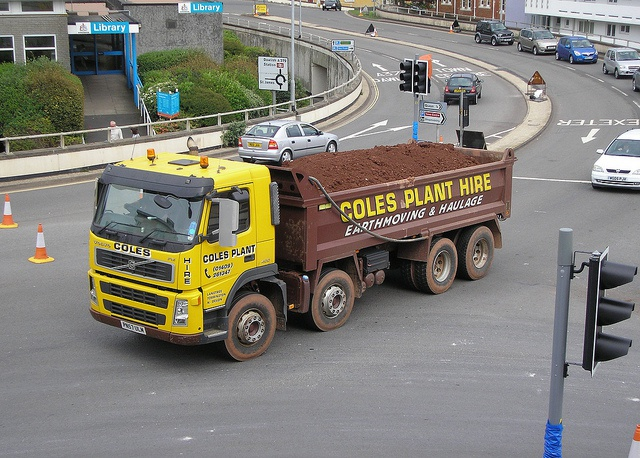Describe the objects in this image and their specific colors. I can see truck in gray, black, and darkgray tones, traffic light in gray, black, and darkgray tones, car in gray, lightgray, darkgray, and black tones, car in gray, white, darkgray, and black tones, and car in gray, navy, and darkgray tones in this image. 